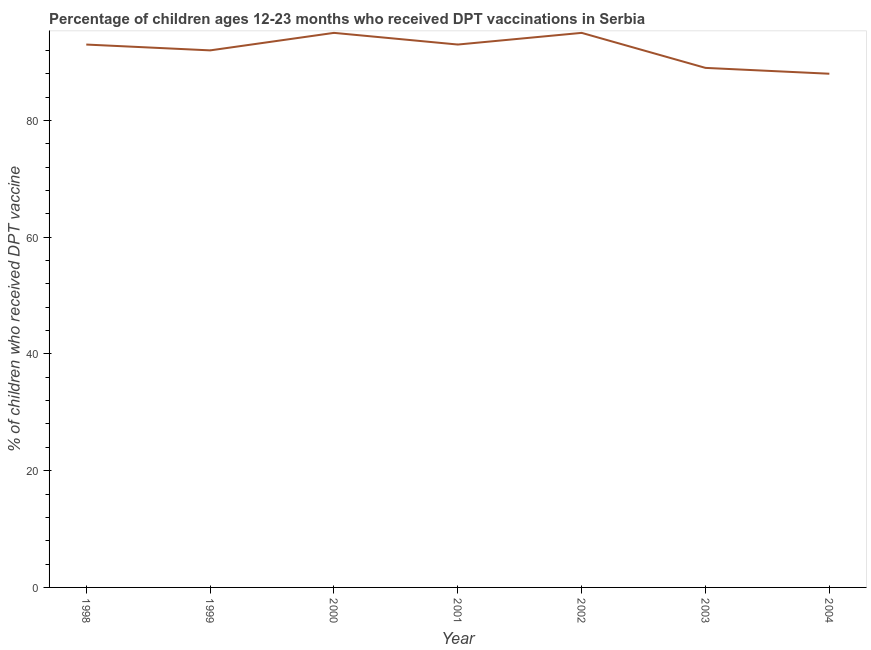What is the percentage of children who received dpt vaccine in 1998?
Your answer should be very brief. 93. Across all years, what is the maximum percentage of children who received dpt vaccine?
Your answer should be compact. 95. Across all years, what is the minimum percentage of children who received dpt vaccine?
Keep it short and to the point. 88. In which year was the percentage of children who received dpt vaccine maximum?
Your answer should be very brief. 2000. In which year was the percentage of children who received dpt vaccine minimum?
Offer a very short reply. 2004. What is the sum of the percentage of children who received dpt vaccine?
Provide a succinct answer. 645. What is the difference between the percentage of children who received dpt vaccine in 1998 and 2002?
Make the answer very short. -2. What is the average percentage of children who received dpt vaccine per year?
Offer a very short reply. 92.14. What is the median percentage of children who received dpt vaccine?
Keep it short and to the point. 93. In how many years, is the percentage of children who received dpt vaccine greater than 16 %?
Your answer should be very brief. 7. Do a majority of the years between 1998 and 2001 (inclusive) have percentage of children who received dpt vaccine greater than 40 %?
Your answer should be compact. Yes. What is the ratio of the percentage of children who received dpt vaccine in 2000 to that in 2003?
Your answer should be very brief. 1.07. Is the percentage of children who received dpt vaccine in 2001 less than that in 2003?
Your answer should be very brief. No. Is the difference between the percentage of children who received dpt vaccine in 1998 and 2000 greater than the difference between any two years?
Your response must be concise. No. What is the difference between the highest and the second highest percentage of children who received dpt vaccine?
Your response must be concise. 0. What is the difference between the highest and the lowest percentage of children who received dpt vaccine?
Ensure brevity in your answer.  7. Does the percentage of children who received dpt vaccine monotonically increase over the years?
Your response must be concise. No. How many lines are there?
Keep it short and to the point. 1. How many years are there in the graph?
Your answer should be compact. 7. What is the difference between two consecutive major ticks on the Y-axis?
Your answer should be very brief. 20. Does the graph contain any zero values?
Offer a very short reply. No. What is the title of the graph?
Your answer should be very brief. Percentage of children ages 12-23 months who received DPT vaccinations in Serbia. What is the label or title of the Y-axis?
Offer a very short reply. % of children who received DPT vaccine. What is the % of children who received DPT vaccine of 1998?
Your answer should be very brief. 93. What is the % of children who received DPT vaccine in 1999?
Provide a short and direct response. 92. What is the % of children who received DPT vaccine of 2000?
Make the answer very short. 95. What is the % of children who received DPT vaccine of 2001?
Provide a succinct answer. 93. What is the % of children who received DPT vaccine in 2002?
Give a very brief answer. 95. What is the % of children who received DPT vaccine of 2003?
Provide a short and direct response. 89. What is the difference between the % of children who received DPT vaccine in 1998 and 1999?
Offer a very short reply. 1. What is the difference between the % of children who received DPT vaccine in 1998 and 2000?
Your answer should be very brief. -2. What is the difference between the % of children who received DPT vaccine in 1998 and 2002?
Offer a terse response. -2. What is the difference between the % of children who received DPT vaccine in 1998 and 2003?
Provide a succinct answer. 4. What is the difference between the % of children who received DPT vaccine in 1999 and 2002?
Offer a very short reply. -3. What is the difference between the % of children who received DPT vaccine in 1999 and 2004?
Your answer should be compact. 4. What is the difference between the % of children who received DPT vaccine in 2000 and 2001?
Your answer should be very brief. 2. What is the difference between the % of children who received DPT vaccine in 2000 and 2002?
Your answer should be compact. 0. What is the difference between the % of children who received DPT vaccine in 2001 and 2003?
Keep it short and to the point. 4. What is the difference between the % of children who received DPT vaccine in 2001 and 2004?
Provide a succinct answer. 5. What is the difference between the % of children who received DPT vaccine in 2003 and 2004?
Offer a terse response. 1. What is the ratio of the % of children who received DPT vaccine in 1998 to that in 1999?
Keep it short and to the point. 1.01. What is the ratio of the % of children who received DPT vaccine in 1998 to that in 2002?
Offer a terse response. 0.98. What is the ratio of the % of children who received DPT vaccine in 1998 to that in 2003?
Your answer should be compact. 1.04. What is the ratio of the % of children who received DPT vaccine in 1998 to that in 2004?
Ensure brevity in your answer.  1.06. What is the ratio of the % of children who received DPT vaccine in 1999 to that in 2002?
Provide a short and direct response. 0.97. What is the ratio of the % of children who received DPT vaccine in 1999 to that in 2003?
Provide a short and direct response. 1.03. What is the ratio of the % of children who received DPT vaccine in 1999 to that in 2004?
Provide a succinct answer. 1.04. What is the ratio of the % of children who received DPT vaccine in 2000 to that in 2002?
Your response must be concise. 1. What is the ratio of the % of children who received DPT vaccine in 2000 to that in 2003?
Your answer should be very brief. 1.07. What is the ratio of the % of children who received DPT vaccine in 2001 to that in 2003?
Provide a short and direct response. 1.04. What is the ratio of the % of children who received DPT vaccine in 2001 to that in 2004?
Your response must be concise. 1.06. What is the ratio of the % of children who received DPT vaccine in 2002 to that in 2003?
Provide a short and direct response. 1.07. What is the ratio of the % of children who received DPT vaccine in 2002 to that in 2004?
Offer a very short reply. 1.08. What is the ratio of the % of children who received DPT vaccine in 2003 to that in 2004?
Offer a very short reply. 1.01. 